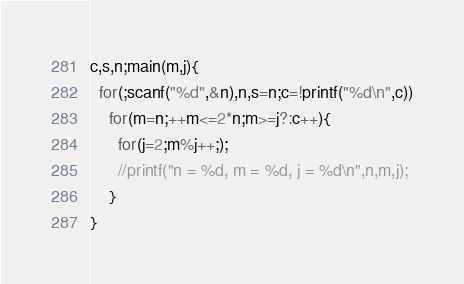<code> <loc_0><loc_0><loc_500><loc_500><_C_>c,s,n;main(m,j){
  for(;scanf("%d",&n),n,s=n;c=!printf("%d\n",c))
    for(m=n;++m<=2*n;m>=j?:c++){
      for(j=2;m%j++;);
      //printf("n = %d, m = %d, j = %d\n",n,m,j);
    }
}</code> 